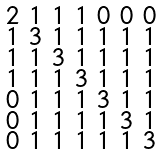<formula> <loc_0><loc_0><loc_500><loc_500>\begin{smallmatrix} 2 & 1 & 1 & 1 & 0 & 0 & 0 \\ 1 & 3 & 1 & 1 & 1 & 1 & 1 \\ 1 & 1 & 3 & 1 & 1 & 1 & 1 \\ 1 & 1 & 1 & 3 & 1 & 1 & 1 \\ 0 & 1 & 1 & 1 & 3 & 1 & 1 \\ 0 & 1 & 1 & 1 & 1 & 3 & 1 \\ 0 & 1 & 1 & 1 & 1 & 1 & 3 \end{smallmatrix}</formula> 